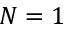Convert formula to latex. <formula><loc_0><loc_0><loc_500><loc_500>N = 1</formula> 